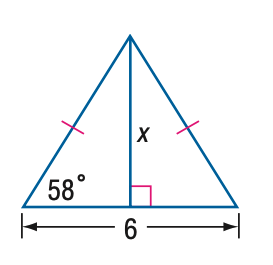In the context of the triangle in the image, how is the tangent function useful? The tangent function is useful in the context of this triangle as it relates the lengths of the opposite side to the adjacent side for a given angle in a right triangle. Seeing as we have a modified isosceles triangle with a right angle, we could use the tangent of one of the base 58-degree angles and the known base length of 6 to find the height of the triangle, which could then be used to find the length of the sides marked as 'x'. Specifically, the tangent of 58 degrees multiplied by 3 (half the base) would give us the height, which is necessary for finding 'x'. 